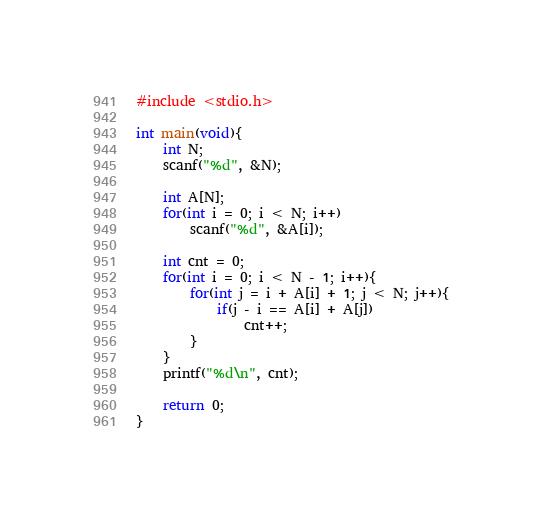Convert code to text. <code><loc_0><loc_0><loc_500><loc_500><_C_>#include <stdio.h>

int main(void){
    int N;
    scanf("%d", &N);

    int A[N];
    for(int i = 0; i < N; i++)
        scanf("%d", &A[i]);

    int cnt = 0;
    for(int i = 0; i < N - 1; i++){
        for(int j = i + A[i] + 1; j < N; j++){
            if(j - i == A[i] + A[j])
                cnt++;
        }
    }
    printf("%d\n", cnt);

    return 0;
}
</code> 